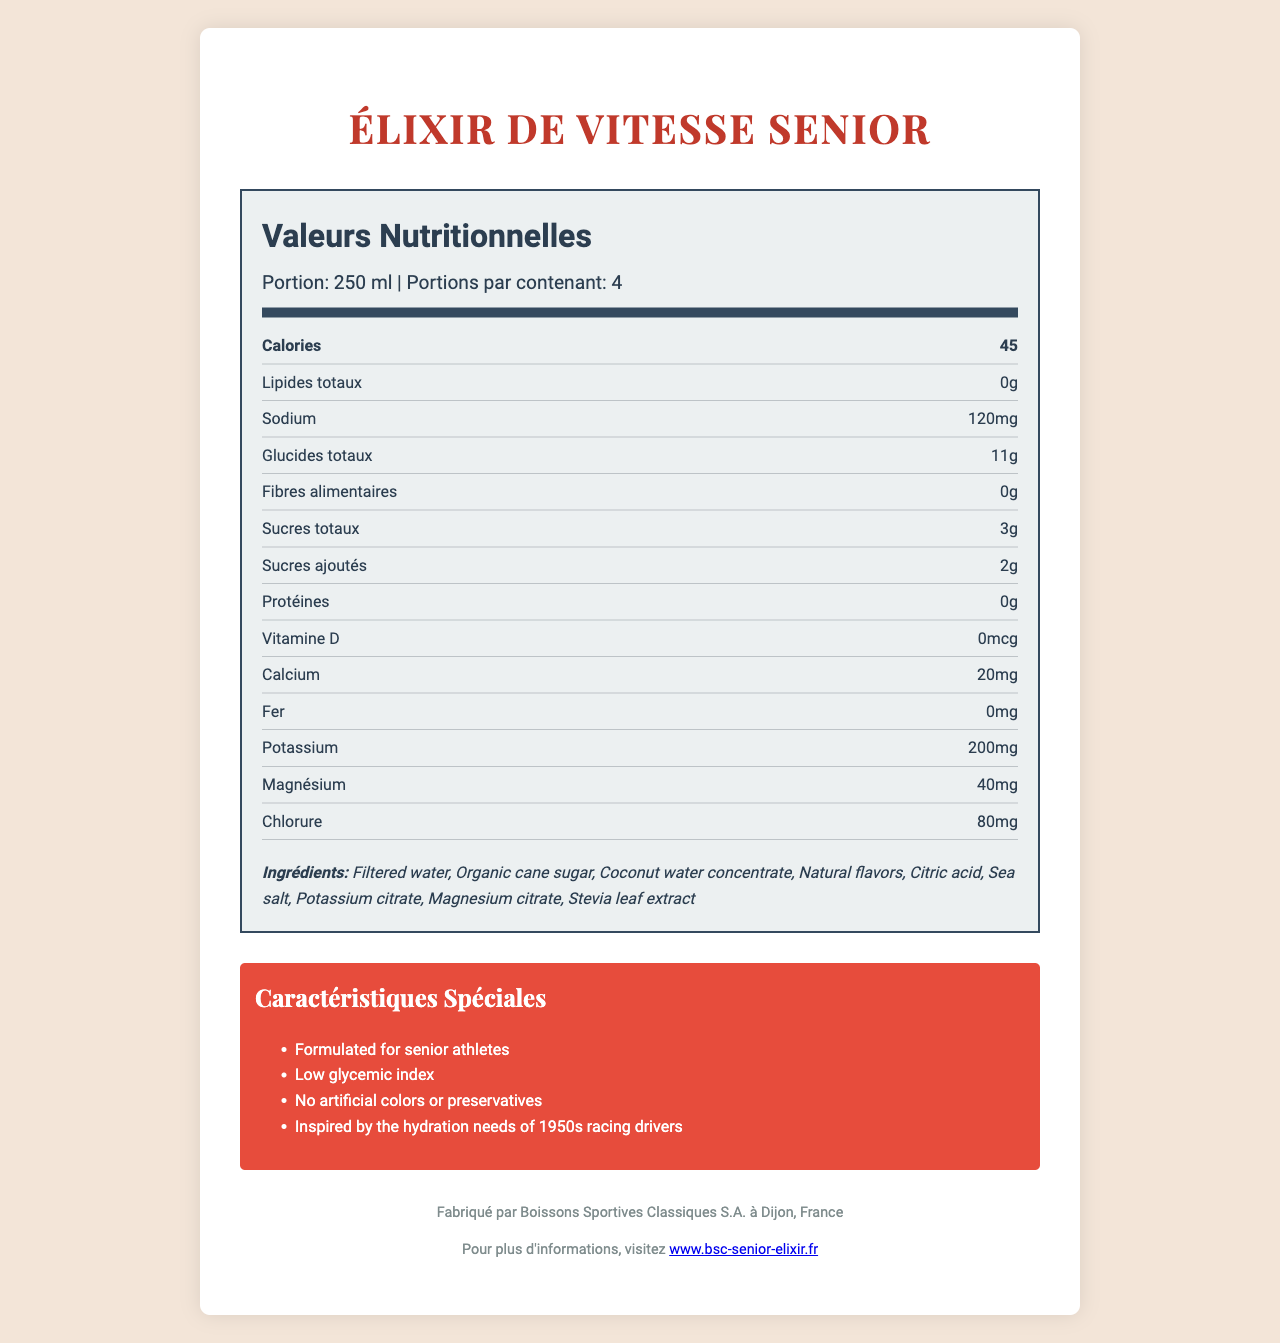who is the manufacturer of Élixir de Vitesse Senior? The manufacturer information is listed towards the end of the document, stating that the product is made by Boissons Sportives Classiques S.A.
Answer: Boissons Sportives Classiques S.A. what is the serving size of Élixir de Vitesse Senior? The serving size is clearly mentioned at the top of the nutrition label.
Answer: 250 ml how many calories are there per serving? The calories per serving information is listed prominently in the nutrition label section.
Answer: 45 how much sugar is in Élixir de Vitesse Senior per serving? The nutrition label specifies that there are 3 grams of total sugars per serving, including 2 grams of added sugars.
Answer: 3g of total sugars with 2g of added sugars what is the main flavor profile? The flavor profile is mentioned in the document where it states "flavorProfile".
Answer: Refreshing Citron-Lavande which special feature does Élixir de Vitesse Senior NOT have? A. Formulated for senior athletes B. Low glycemic index C. Contains artificial colors D. No artificial preservatives The document lists “No artificial colors or preservatives” among the special features, indicating it does not contain artificial colors.
Answer: C. Contains artificial colors how many servings are there per container? A. 2 B. 3 C. 4 D. 5 The servings per container information is listed under the serving info section in the nutrition label.
Answer: C. 4 is Élixir de Vitesse Senior certified organic? The document states that the product is "Certified Organic by Agriculture Biologique".
Answer: Yes summarize the main features of Élixir de Vitesse Senior The document highlights several key features, including its targeted design for senior athletes, balanced electrolyte content, and low sugar levels. It also mentions the product's flavor and organic certification, as well as its historical inspiration and special features.
Answer: Élixir de Vitesse Senior is a gourmet French sports drink designed for senior athletes with a focus on balanced electrolytes and low sugar content. It has a refreshing Citron-Lavande flavor and is formulated without artificial colors or preservatives. The drink is organically certified by Agriculture Biologique and approved by the French Society of Sports Nutrition. Inspired by the hydration needs of 1950s racing drivers, it is gentle on digestion and claims to revive the spirit of Le Mans 1955. what is the location of the manufacturing company? The manufacturer information section clearly states the location of the company as Dijon, France.
Answer: Dijon, France how much potassium is in one serving? The nutrition label shows the amount of potassium per serving as 200mg.
Answer: 200mg does Élixir de Vitesse Senior have any protein content? The nutrition label specifies that the protein content per serving is 0 grams.
Answer: No which electrolyte is present in the greatest amount per serving? Among the electrolytes listed in the nutrition label (sodium, potassium, magnesium, chloride), potassium has the highest amount with 200mg per serving.
Answer: Potassium where can more information about Élixir de Vitesse Senior be found online? The manufacturer's information section at the end of the document provides the website URL for more information.
Answer: www.bsc-senior-elixir.fr what is the glycemic index of Élixir de Vitesse Senior? The document mentions it has a low glycemic index but does not provide the exact value.
Answer: Not enough information 